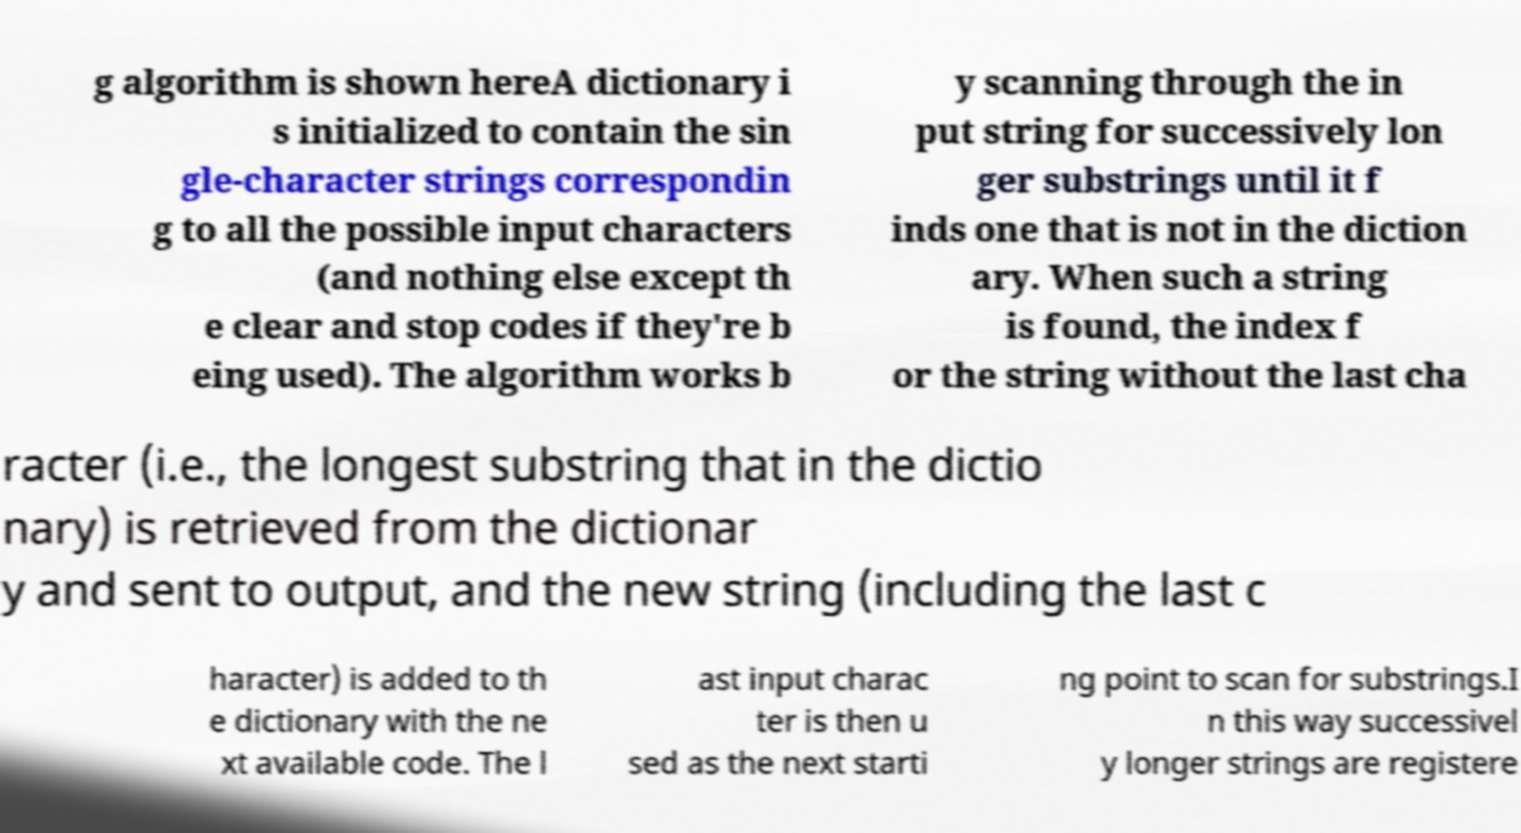Please identify and transcribe the text found in this image. g algorithm is shown hereA dictionary i s initialized to contain the sin gle-character strings correspondin g to all the possible input characters (and nothing else except th e clear and stop codes if they're b eing used). The algorithm works b y scanning through the in put string for successively lon ger substrings until it f inds one that is not in the diction ary. When such a string is found, the index f or the string without the last cha racter (i.e., the longest substring that in the dictio nary) is retrieved from the dictionar y and sent to output, and the new string (including the last c haracter) is added to th e dictionary with the ne xt available code. The l ast input charac ter is then u sed as the next starti ng point to scan for substrings.I n this way successivel y longer strings are registere 